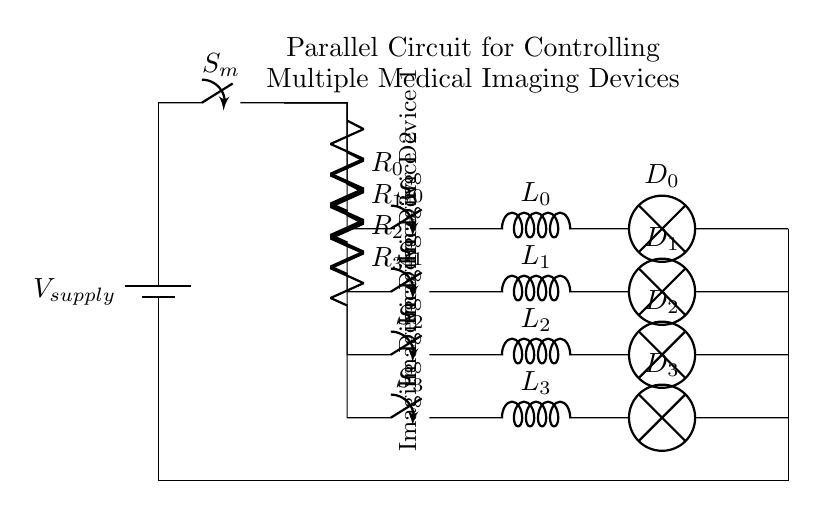What type of circuit is used in this diagram? This diagram illustrates a parallel circuit, characterized by multiple branches connected to the same voltage source. Each branch operates independently and can be controlled separately.
Answer: Parallel circuit How many imaging devices are controlled in this circuit? There are four imaging devices labeled from 1 to 4 in the diagram. Each device is connected to a separate branch within the parallel circuit.
Answer: Four What component type connects the power supply to the switches? A main switch is depicted connecting the power supply to the parallel branches that lead to the imaging devices. This switch allows for controlling the supply of power to all devices simultaneously.
Answer: Main switch What is the function of the resistors in the circuit? The resistors are present in each branch and are typically used to limit the current flowing through each device, thus protecting them from potential damage due to excess current.
Answer: Current limiting If one device fails, what happens to the others? In a parallel circuit, the other devices continue to operate normally even if one device fails, as each branch is independent. This is a significant advantage of parallel circuits in applications such as medical imaging.
Answer: They remain operational What type of elements are used at the end of each branch? Each branch ends with a lamp, which typically represents the output indicator for each imaging device, signaling its operational status. The lamp illuminates when the corresponding device is active.
Answer: Lamp 